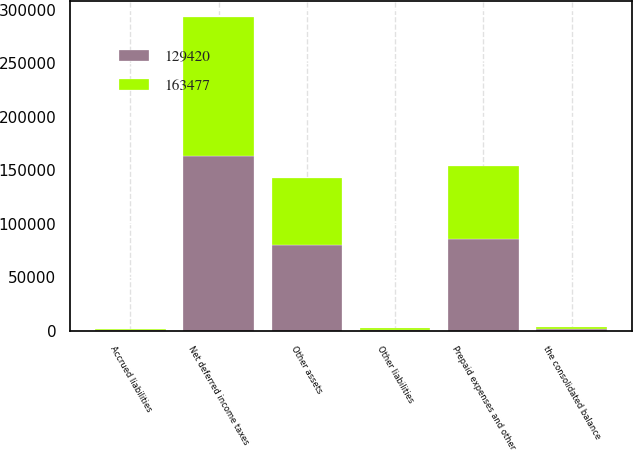Convert chart. <chart><loc_0><loc_0><loc_500><loc_500><stacked_bar_chart><ecel><fcel>the consolidated balance<fcel>Prepaid expenses and other<fcel>Other assets<fcel>Accrued liabilities<fcel>Other liabilities<fcel>Net deferred income taxes<nl><fcel>129420<fcel>2012<fcel>85429<fcel>79746<fcel>641<fcel>1057<fcel>163477<nl><fcel>163477<fcel>2011<fcel>68774<fcel>62574<fcel>731<fcel>1197<fcel>129420<nl></chart> 